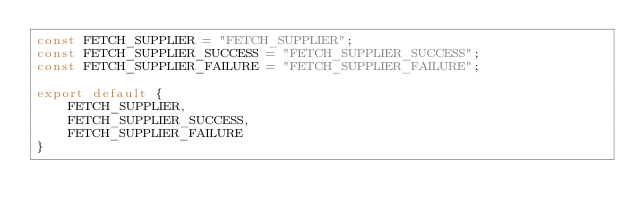<code> <loc_0><loc_0><loc_500><loc_500><_JavaScript_>const FETCH_SUPPLIER = "FETCH_SUPPLIER";
const FETCH_SUPPLIER_SUCCESS = "FETCH_SUPPLIER_SUCCESS";
const FETCH_SUPPLIER_FAILURE = "FETCH_SUPPLIER_FAILURE";

export default {
    FETCH_SUPPLIER,
    FETCH_SUPPLIER_SUCCESS,
    FETCH_SUPPLIER_FAILURE
}</code> 